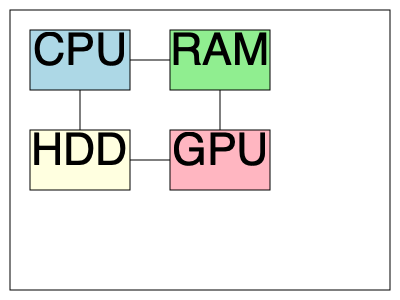In the given computer hardware schematic, which component is responsible for temporarily storing data and instructions that are actively being used by the system? To answer this question, let's examine the components shown in the schematic:

1. CPU (Central Processing Unit): This is the "brain" of the computer, responsible for executing instructions and performing calculations.

2. RAM (Random Access Memory): This is the component that temporarily stores data and instructions that are actively being used by the system.

3. HDD (Hard Disk Drive): This is a storage device that permanently stores data, even when the computer is powered off.

4. GPU (Graphics Processing Unit): This component is specialized for rendering graphics and video.

Among these components, RAM is specifically designed for temporary storage of active data and instructions. It provides fast access to information that the CPU needs to process quickly. When a program is running, its instructions and data are loaded into RAM for rapid access by the CPU.

The other components have different primary functions:
- CPU processes instructions
- HDD provides long-term storage
- GPU handles graphics processing

Therefore, the component responsible for temporarily storing data and instructions that are actively being used by the system is RAM.
Answer: RAM (Random Access Memory) 